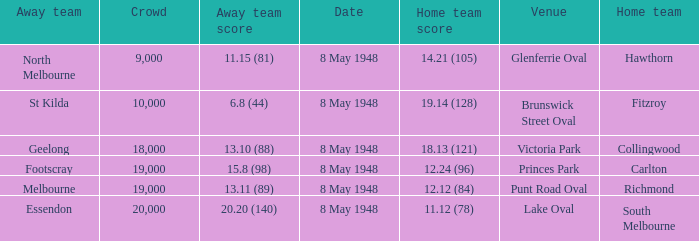How many spectators were at the game when the away team scored 15.8 (98)? 19000.0. 